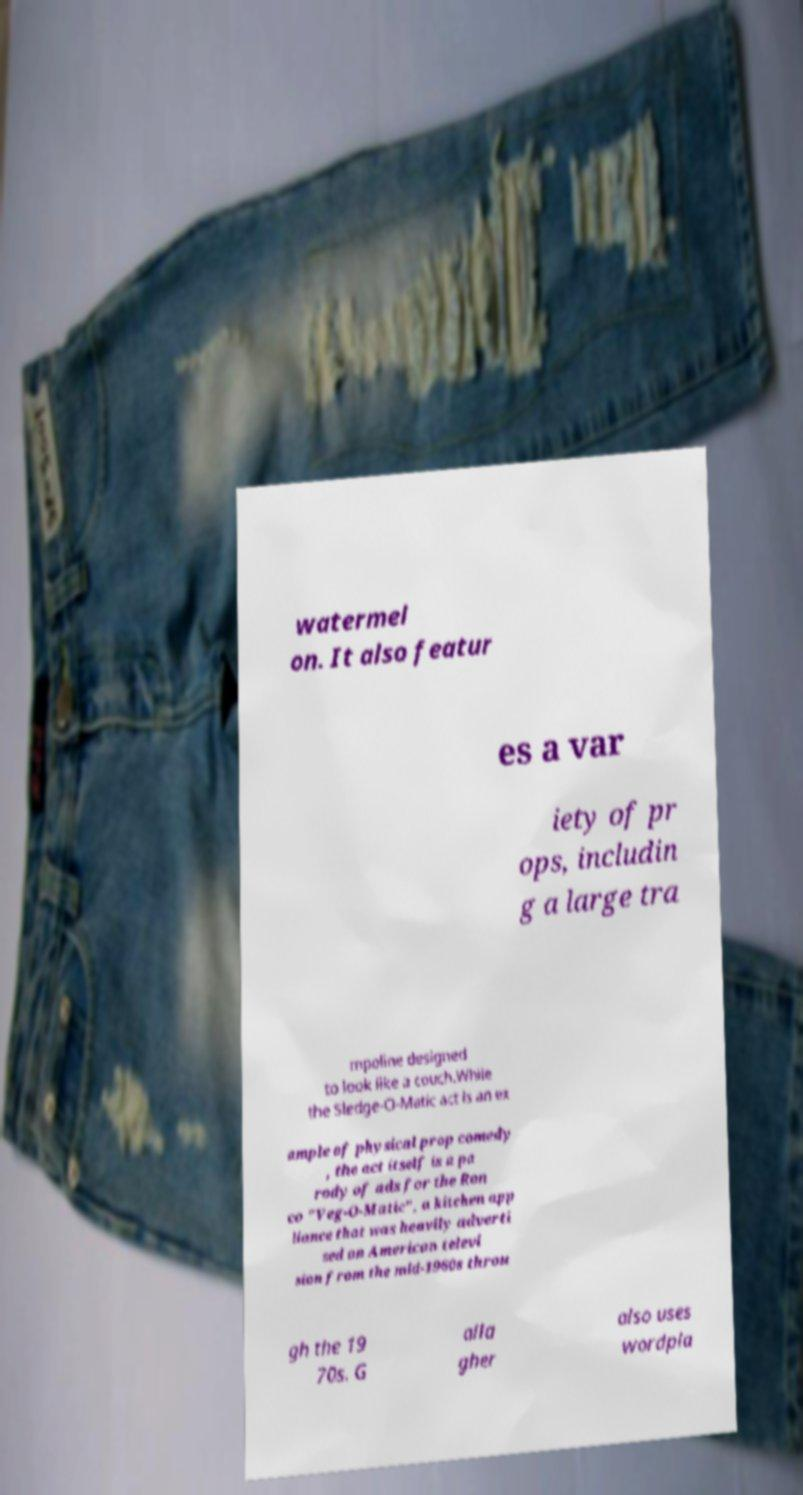For documentation purposes, I need the text within this image transcribed. Could you provide that? watermel on. It also featur es a var iety of pr ops, includin g a large tra mpoline designed to look like a couch.While the Sledge-O-Matic act is an ex ample of physical prop comedy , the act itself is a pa rody of ads for the Ron co "Veg-O-Matic", a kitchen app liance that was heavily adverti sed on American televi sion from the mid-1960s throu gh the 19 70s. G alla gher also uses wordpla 